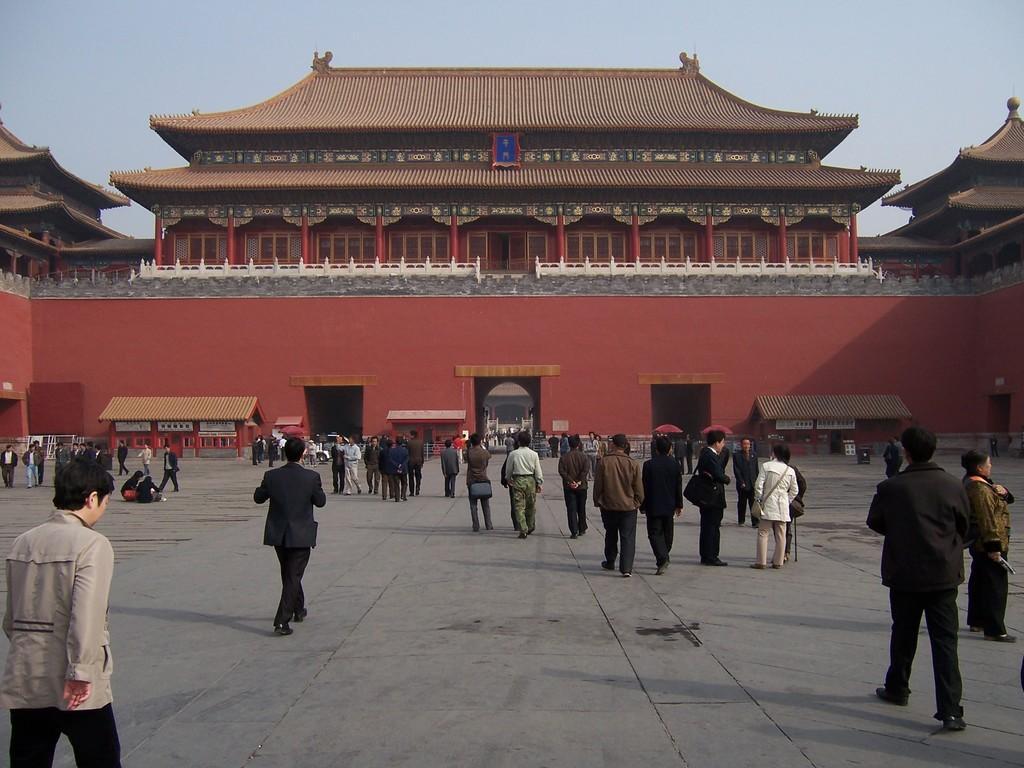Can you describe this image briefly? In this image, we can see a crowd. There is a building in the middle of the image. There is a sky at the top of the image. 